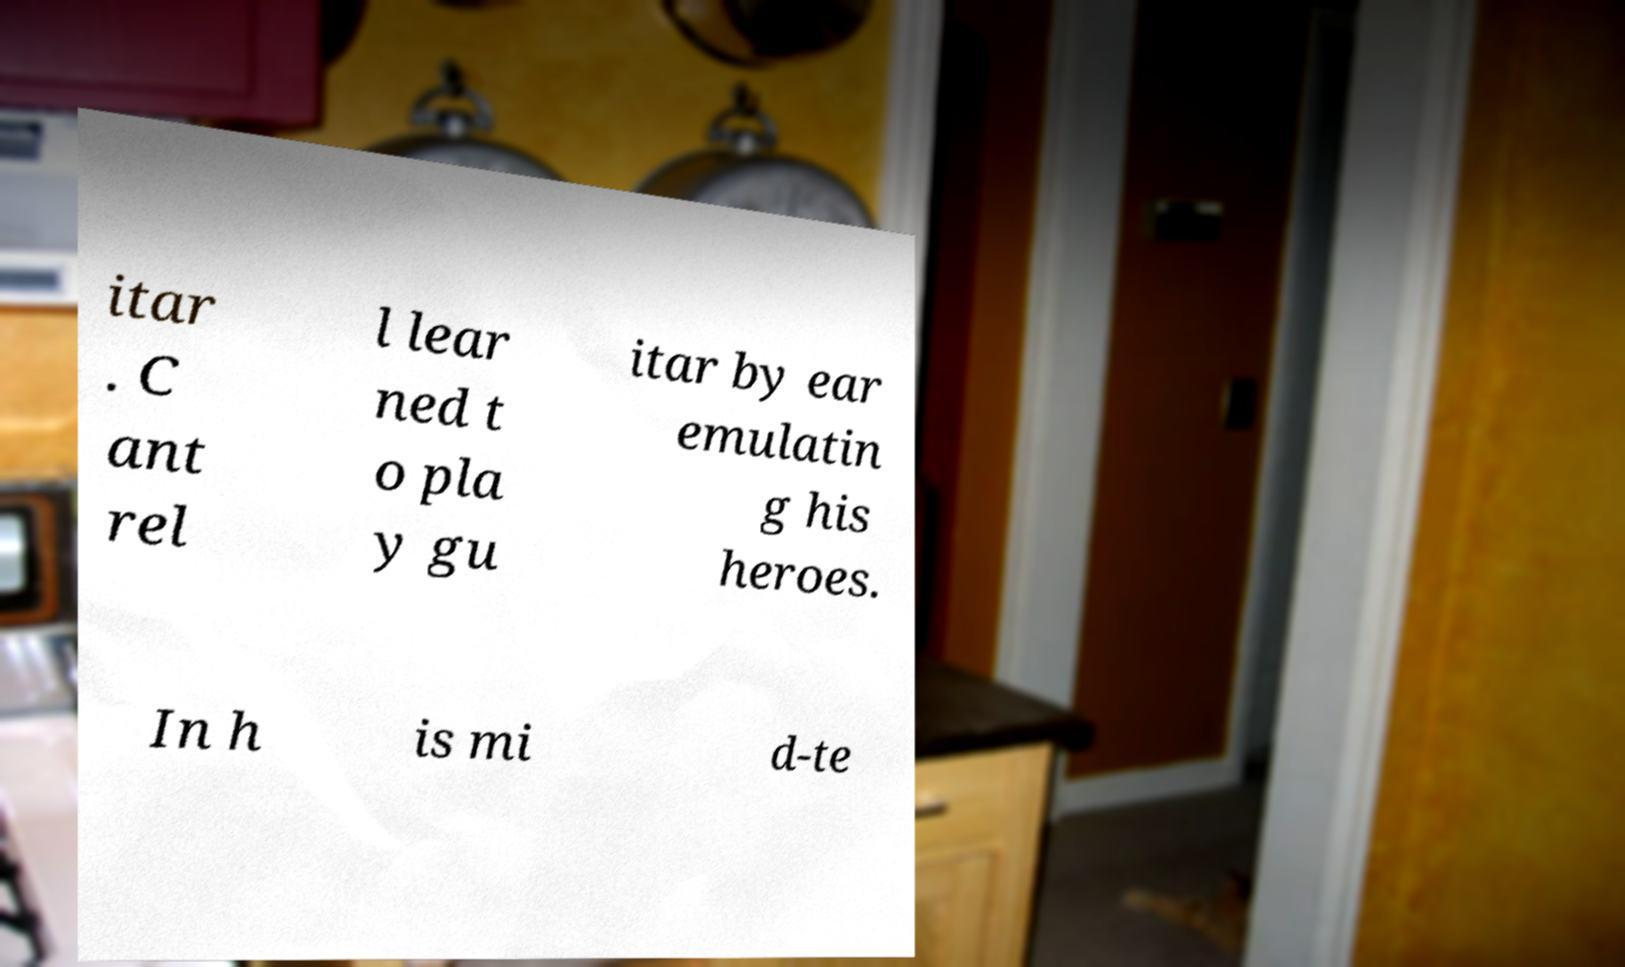Please identify and transcribe the text found in this image. itar . C ant rel l lear ned t o pla y gu itar by ear emulatin g his heroes. In h is mi d-te 